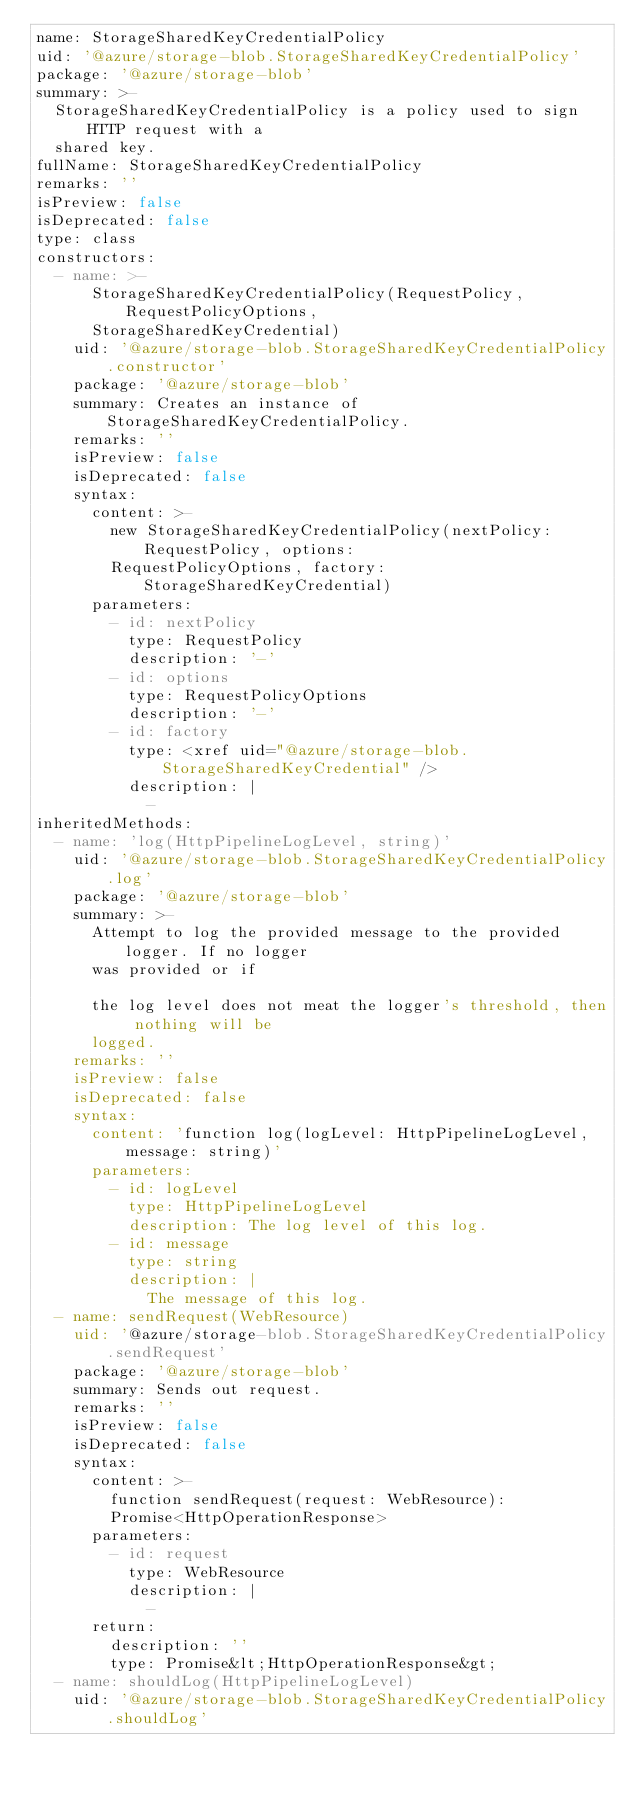<code> <loc_0><loc_0><loc_500><loc_500><_YAML_>name: StorageSharedKeyCredentialPolicy
uid: '@azure/storage-blob.StorageSharedKeyCredentialPolicy'
package: '@azure/storage-blob'
summary: >-
  StorageSharedKeyCredentialPolicy is a policy used to sign HTTP request with a
  shared key.
fullName: StorageSharedKeyCredentialPolicy
remarks: ''
isPreview: false
isDeprecated: false
type: class
constructors:
  - name: >-
      StorageSharedKeyCredentialPolicy(RequestPolicy, RequestPolicyOptions,
      StorageSharedKeyCredential)
    uid: '@azure/storage-blob.StorageSharedKeyCredentialPolicy.constructor'
    package: '@azure/storage-blob'
    summary: Creates an instance of StorageSharedKeyCredentialPolicy.
    remarks: ''
    isPreview: false
    isDeprecated: false
    syntax:
      content: >-
        new StorageSharedKeyCredentialPolicy(nextPolicy: RequestPolicy, options:
        RequestPolicyOptions, factory: StorageSharedKeyCredential)
      parameters:
        - id: nextPolicy
          type: RequestPolicy
          description: '-'
        - id: options
          type: RequestPolicyOptions
          description: '-'
        - id: factory
          type: <xref uid="@azure/storage-blob.StorageSharedKeyCredential" />
          description: |
            -
inheritedMethods:
  - name: 'log(HttpPipelineLogLevel, string)'
    uid: '@azure/storage-blob.StorageSharedKeyCredentialPolicy.log'
    package: '@azure/storage-blob'
    summary: >-
      Attempt to log the provided message to the provided logger. If no logger
      was provided or if

      the log level does not meat the logger's threshold, then nothing will be
      logged.
    remarks: ''
    isPreview: false
    isDeprecated: false
    syntax:
      content: 'function log(logLevel: HttpPipelineLogLevel, message: string)'
      parameters:
        - id: logLevel
          type: HttpPipelineLogLevel
          description: The log level of this log.
        - id: message
          type: string
          description: |
            The message of this log.
  - name: sendRequest(WebResource)
    uid: '@azure/storage-blob.StorageSharedKeyCredentialPolicy.sendRequest'
    package: '@azure/storage-blob'
    summary: Sends out request.
    remarks: ''
    isPreview: false
    isDeprecated: false
    syntax:
      content: >-
        function sendRequest(request: WebResource):
        Promise<HttpOperationResponse>
      parameters:
        - id: request
          type: WebResource
          description: |
            -
      return:
        description: ''
        type: Promise&lt;HttpOperationResponse&gt;
  - name: shouldLog(HttpPipelineLogLevel)
    uid: '@azure/storage-blob.StorageSharedKeyCredentialPolicy.shouldLog'</code> 